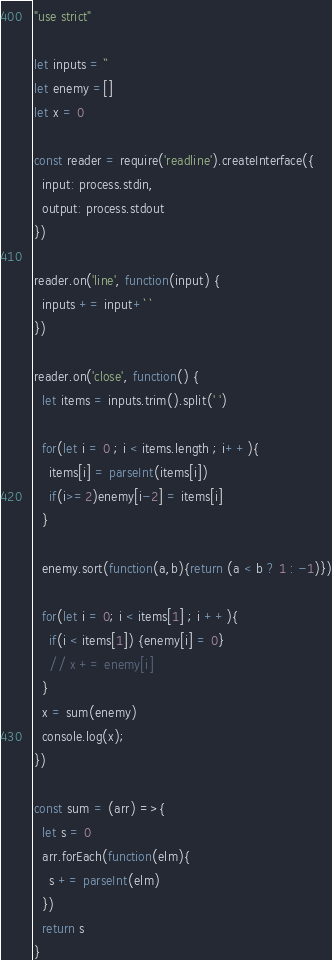Convert code to text. <code><loc_0><loc_0><loc_500><loc_500><_JavaScript_>"use strict"

let inputs = ``
let enemy =[]
let x = 0

const reader = require('readline').createInterface({
  input: process.stdin,
  output: process.stdout
})

reader.on('line', function(input) {
  inputs += input+` `
})

reader.on('close', function() {
  let items = inputs.trim().split(' ')
  
  for(let i = 0 ; i < items.length ; i++){
    items[i] = parseInt(items[i])
    if(i>=2)enemy[i-2] = items[i]
  }

  enemy.sort(function(a,b){return (a < b ? 1 : -1)})
  
  for(let i = 0; i < items[1] ; i ++){
    if(i < items[1]) {enemy[i] = 0}
    // x += enemy[i]
  }
  x = sum(enemy)
  console.log(x);
})

const sum = (arr) =>{
  let s = 0
  arr.forEach(function(elm){
    s += parseInt(elm)
  })
  return s
}</code> 